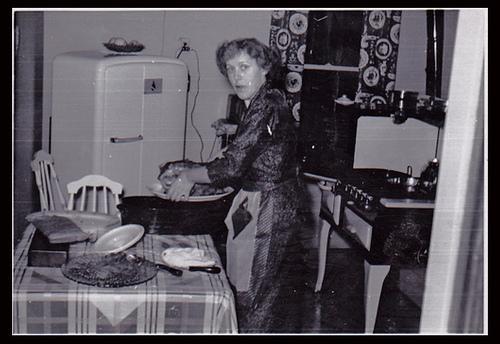How many people are there?
Give a very brief answer. 1. 